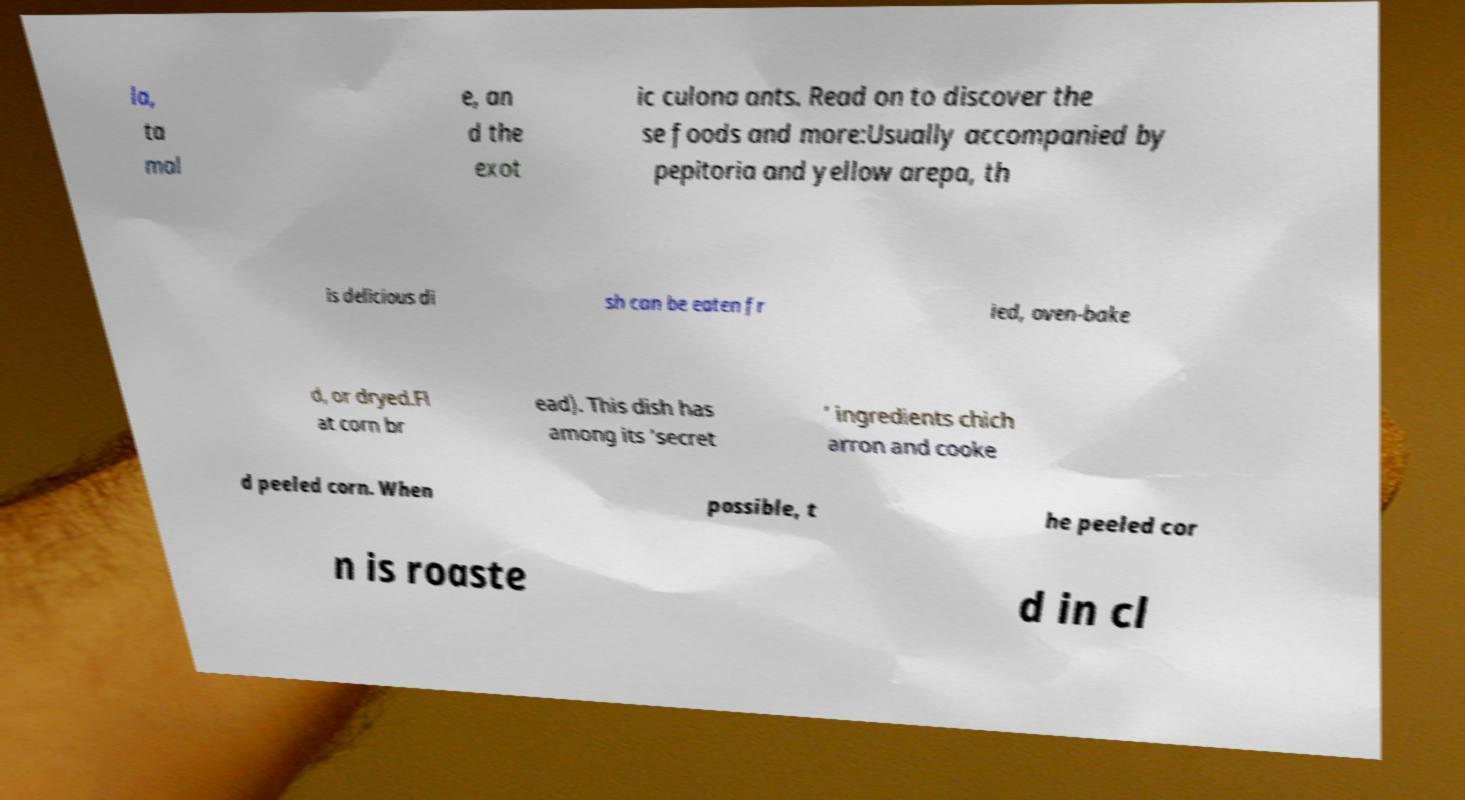For documentation purposes, I need the text within this image transcribed. Could you provide that? la, ta mal e, an d the exot ic culona ants. Read on to discover the se foods and more:Usually accompanied by pepitoria and yellow arepa, th is delicious di sh can be eaten fr ied, oven-bake d, or dryed.Fl at corn br ead). This dish has among its ‘secret ’ ingredients chich arron and cooke d peeled corn. When possible, t he peeled cor n is roaste d in cl 